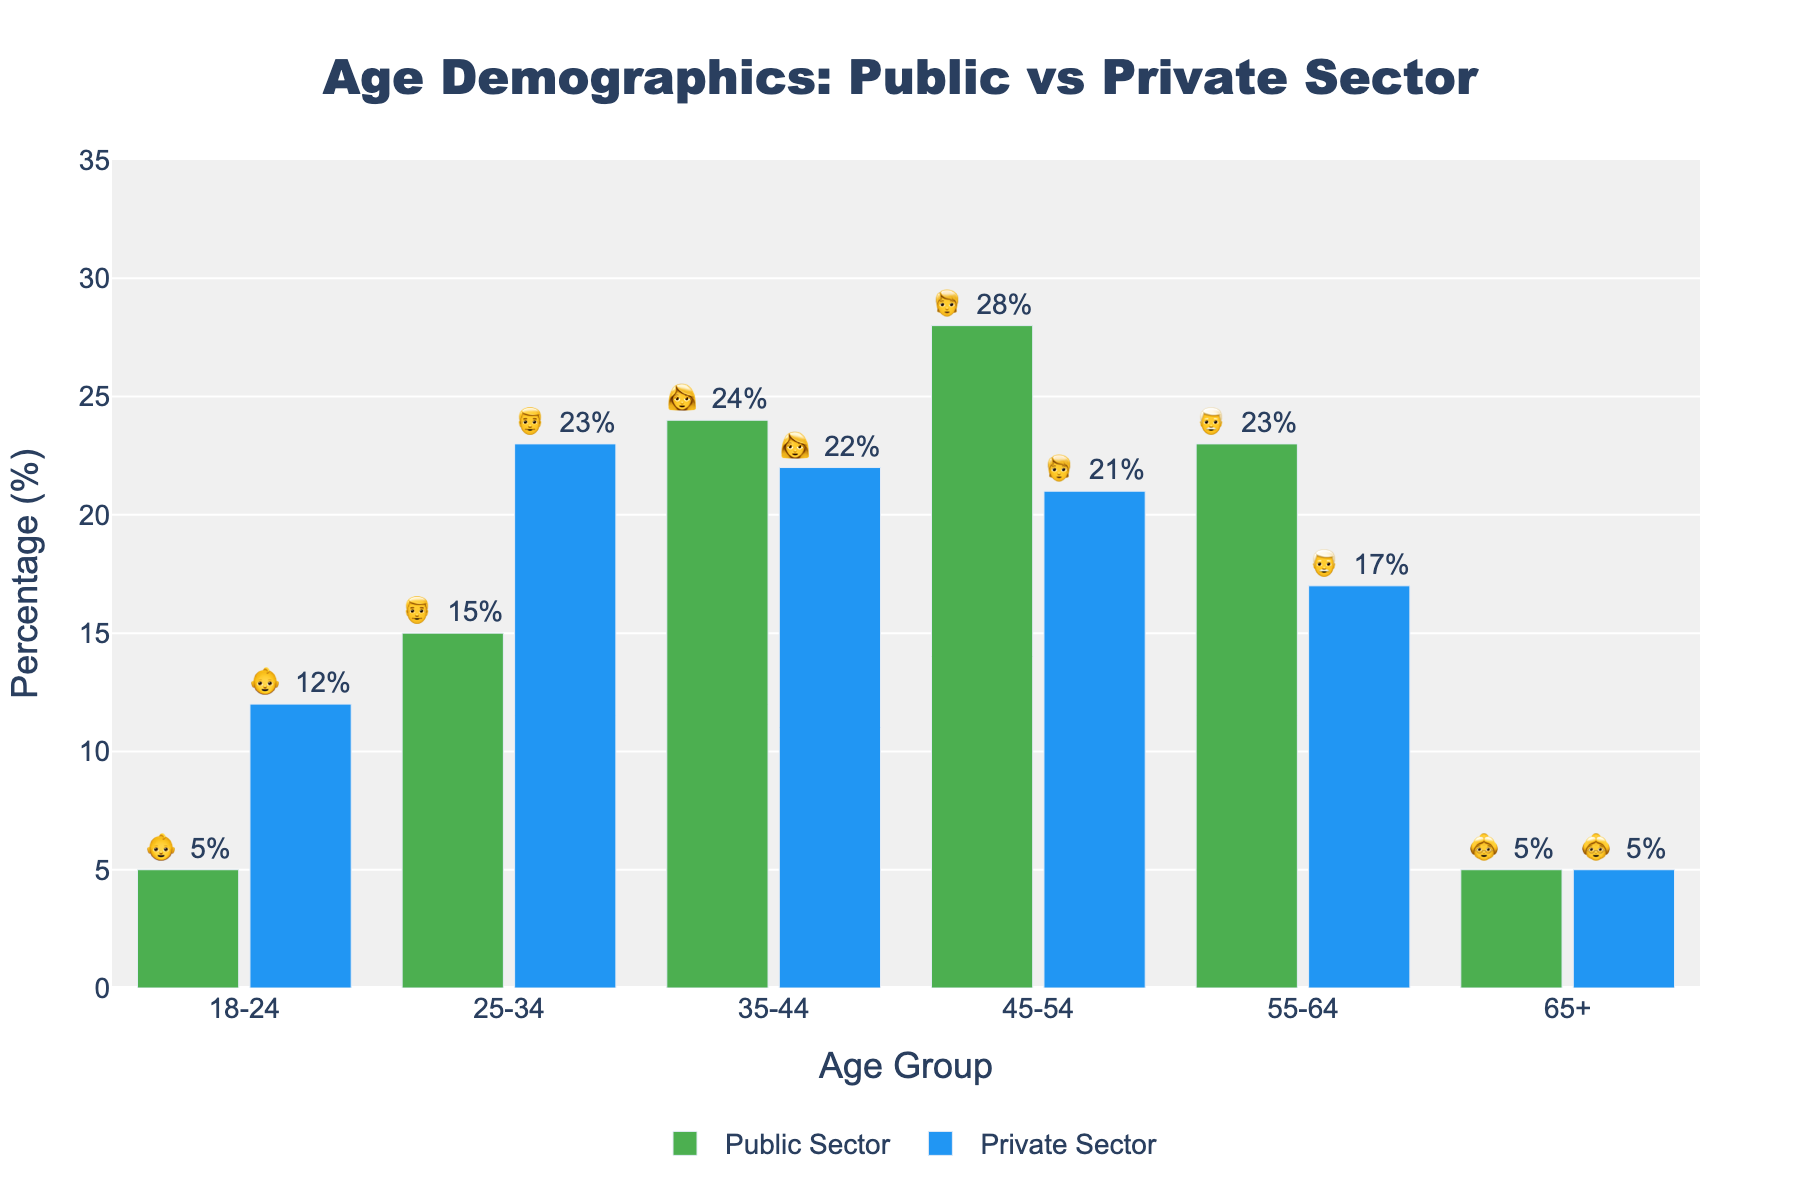What is the title of the chart? The title appears at the top of the chart and provides an overview of what the chart represents. In this case, it indicates a comparison of age demographics between the public and private sectors.
Answer: Age Demographics: Public vs Private Sector What is the percentage of 25-34 year-olds in the public sector? Look at the bar corresponding to the age group 25-34 and check the label indicating the percentage for the public sector column.
Answer: 15% Which age group has the highest percentage in the public sector? Examine the heights of all the bars for the public sector and identify the tallest one. The corresponding age group will have the highest percentage.
Answer: 45-54 How do the percentages of 18-24 year-olds compare between the public and private sectors? Compare the heights of the bars and the percentage labels for the age group 18-24 in both the public and private sectors.
Answer: 5% in public sector, 12% in private sector What is the sum of the percentages for age groups 55-64 and 65+ in the private sector? Add the percentages for the age groups 55-64 and 65+ from the private sector column. 17% + 5% = 22%
Answer: 22% In which sector is the workforce younger on average? Younger age groups generally have higher percentages in the private sector (18-24, 25-34), suggesting a younger workforce on average compared to the public sector.
Answer: Private sector Which sector has the same percentage for the 65+ age group? Check both public and private sector bars for the 65+ age group and observe that both percentages are the same.
Answer: Both sectors have 5% What is the difference in percentage for the 45-54 age group between the public and private sectors? Subtract the percentage of the 45-54 age group in the private sector from that in the public sector. 28% - 21% = 7%
Answer: 7% Which age group has nearly equal representation in both sectors? Look for age groups where the percentages for public and private sectors are close. For the age group 35-44, the percentages are 24% in the public sector and 22% in the private sector.
Answer: 35-44 What's the total percentage of public sector workforce for all age groups combined? Add the percentages of all age groups in the public sector: 5 + 15 + 24 + 28 + 23 + 5 = 100
Answer: 100% 